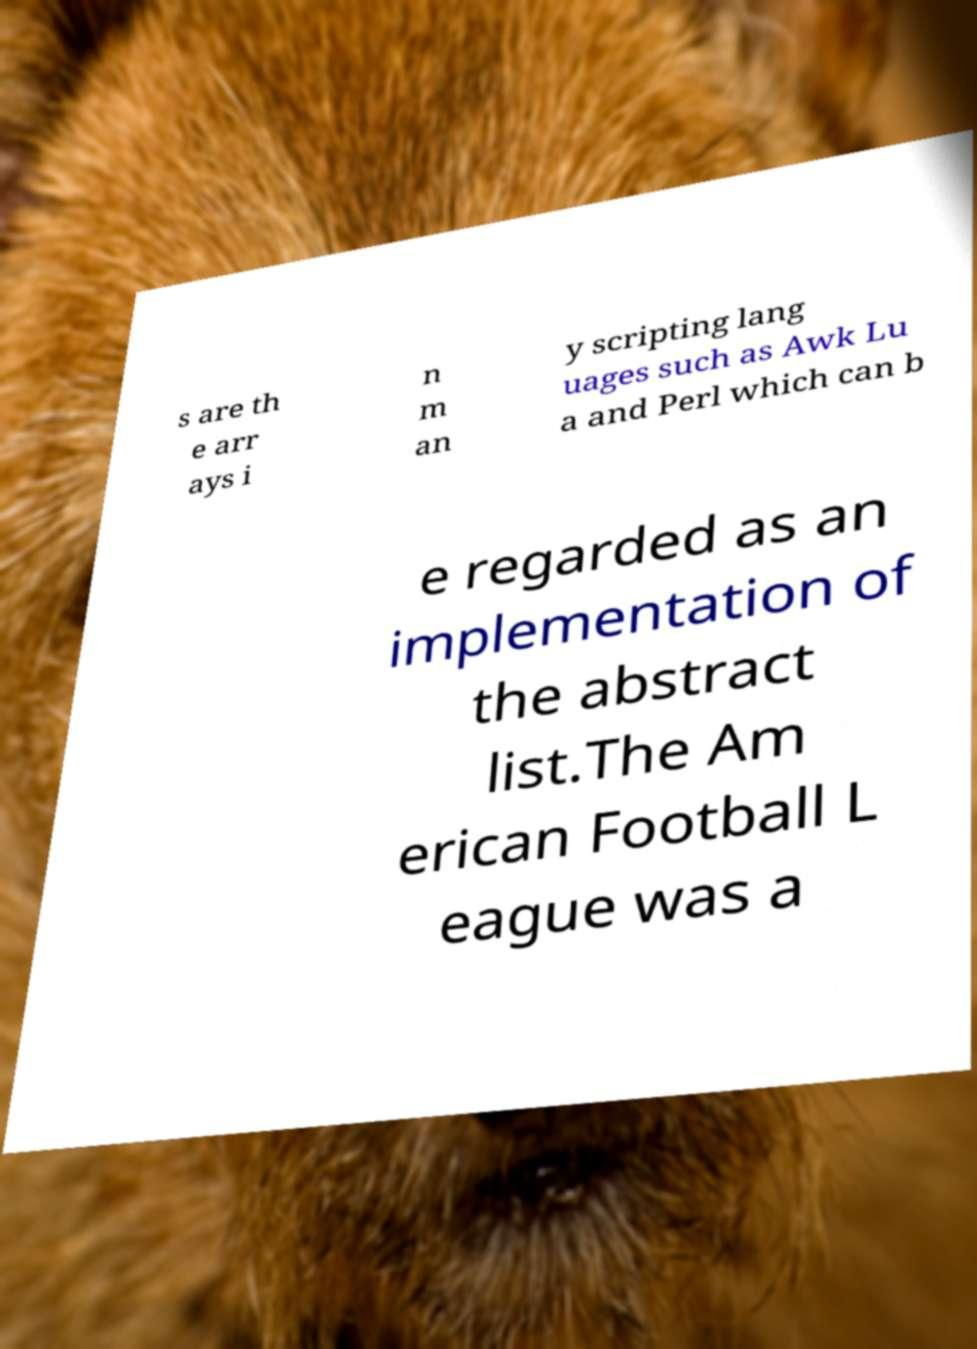Can you read and provide the text displayed in the image?This photo seems to have some interesting text. Can you extract and type it out for me? s are th e arr ays i n m an y scripting lang uages such as Awk Lu a and Perl which can b e regarded as an implementation of the abstract list.The Am erican Football L eague was a 